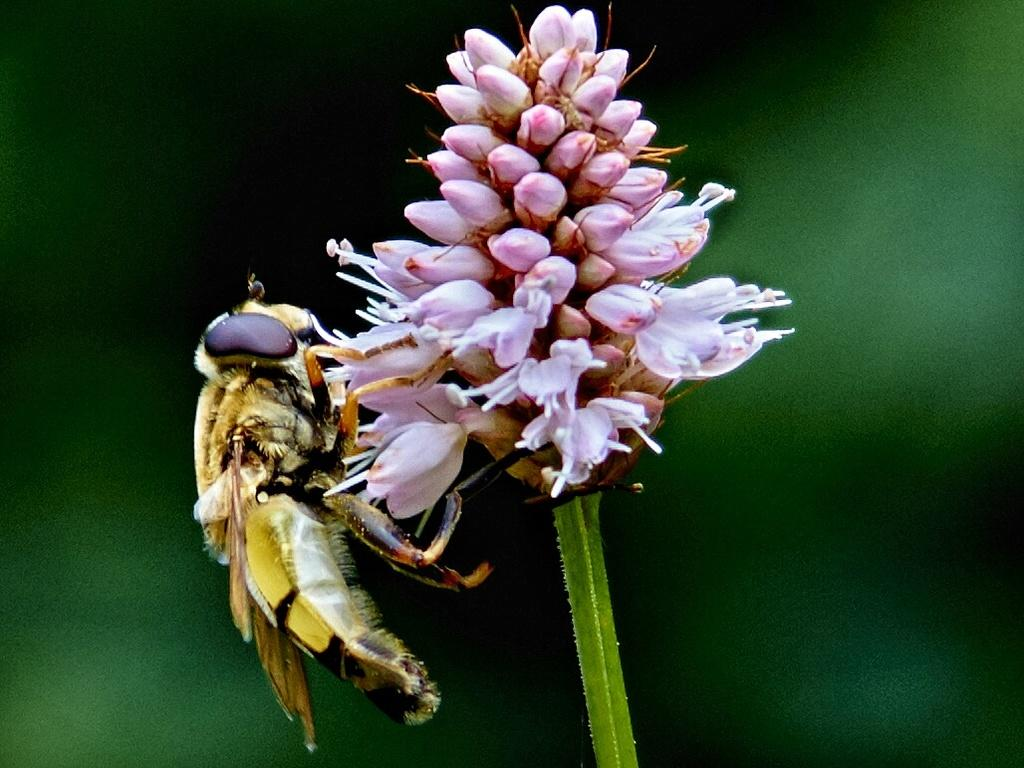What is on the flowers in the image? There is an insect on the flowers. What stage of growth are the flowers in? Flower buds are present in the image. What connects the flowers to the stem? There is a stem visible in the image. How would you describe the background of the image? The background of the image is blurred. How many mice are playing basketball in the image? There are no mice or basketballs present in the image. 